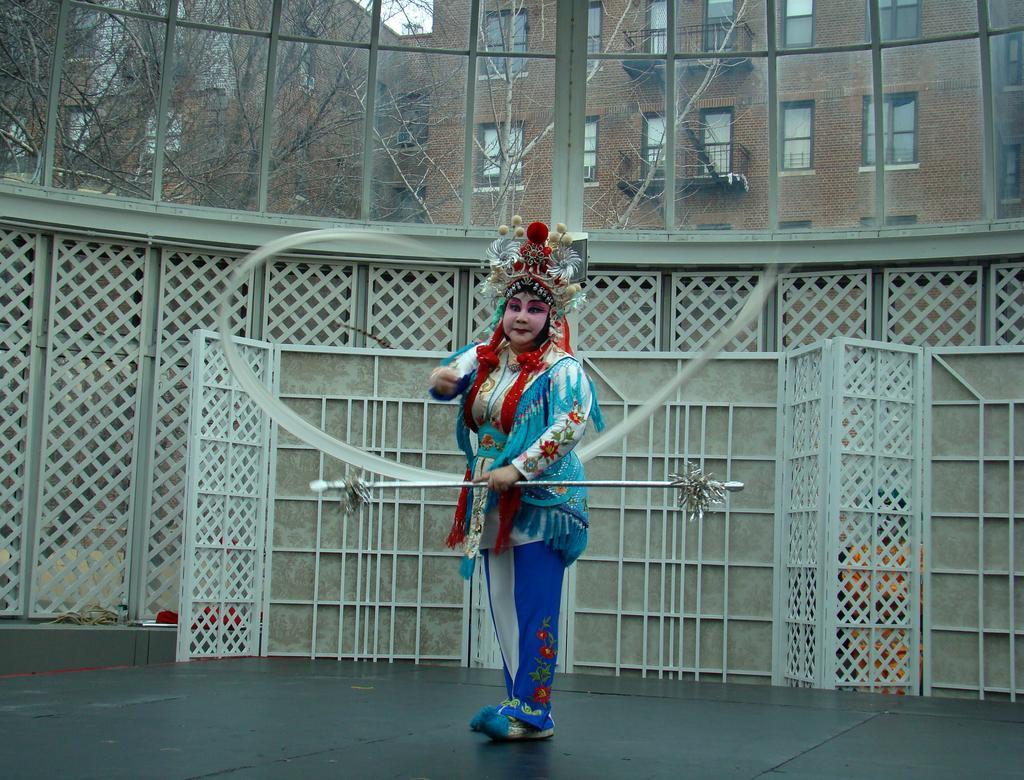Describe this image in one or two sentences. In the foreground of this image, there is a woman in cosplay and holding a stick. In the background, there is a wooden wall. On the top, there is a glass wall. Through the glass, we can see, buildings, trees and the sky. 